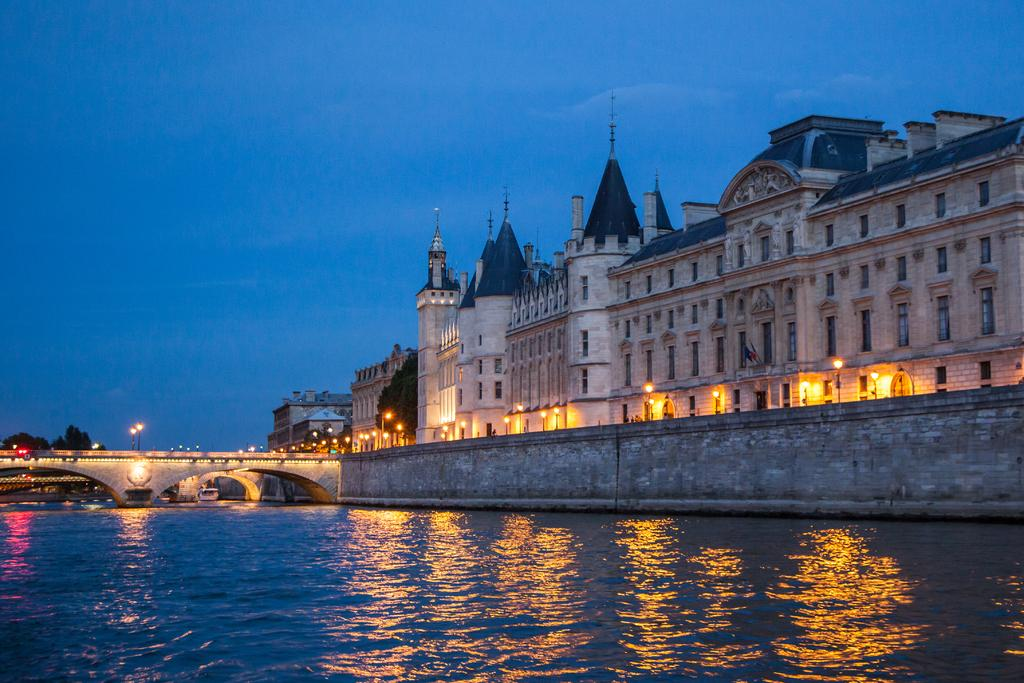What is at the bottom of the image? There is a surface of water at the bottom of the image. What can be seen in the image besides the water? There are trees, a bridge, lights, and a building in the image. What connects the two sides of the water in the image? There is a bridge in the image. What might be used for illumination in the image? There are lights in the image. What type of structure is visible in the image? There is a building in the image. What is visible in the background of the image? The sky is visible in the background of the image. What is the purpose of the stomach in the image? There is no stomach present in the image. How does the bridge talk to the trees in the image? The bridge does not talk to the trees in the image; it is an inanimate object. 